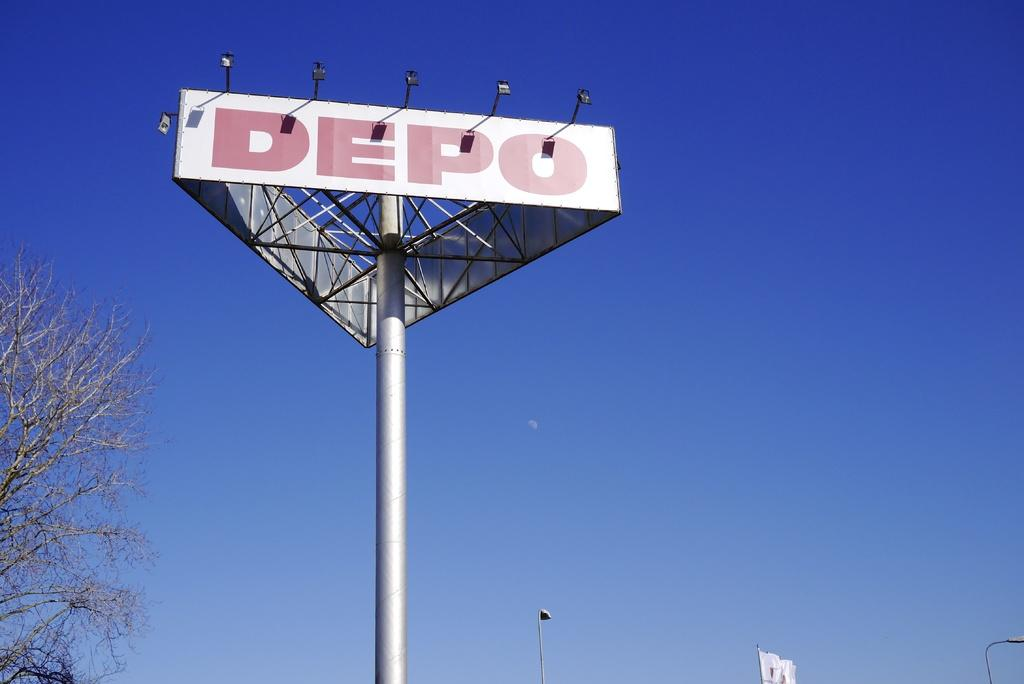<image>
Describe the image concisely. A sign for the DEPOT has a triangular shape and sits atop a silver pole. 